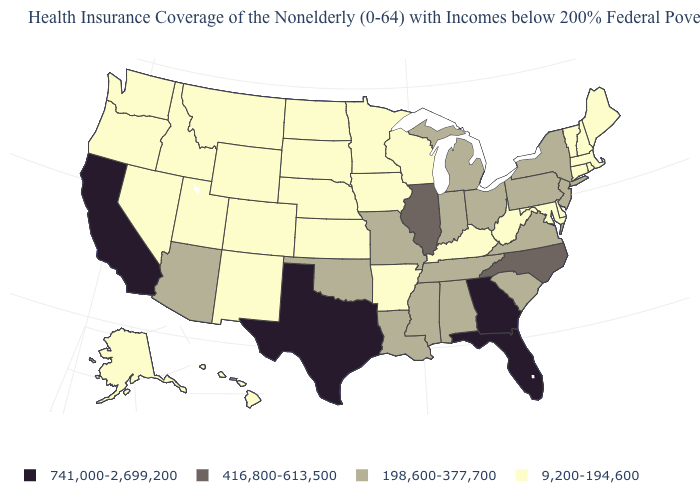Which states have the highest value in the USA?
Answer briefly. California, Florida, Georgia, Texas. Among the states that border Ohio , which have the lowest value?
Keep it brief. Kentucky, West Virginia. What is the value of New Hampshire?
Give a very brief answer. 9,200-194,600. What is the value of Ohio?
Concise answer only. 198,600-377,700. What is the value of Montana?
Concise answer only. 9,200-194,600. Name the states that have a value in the range 416,800-613,500?
Give a very brief answer. Illinois, North Carolina. What is the highest value in states that border Delaware?
Give a very brief answer. 198,600-377,700. What is the value of Maryland?
Answer briefly. 9,200-194,600. Name the states that have a value in the range 198,600-377,700?
Concise answer only. Alabama, Arizona, Indiana, Louisiana, Michigan, Mississippi, Missouri, New Jersey, New York, Ohio, Oklahoma, Pennsylvania, South Carolina, Tennessee, Virginia. Which states have the highest value in the USA?
Be succinct. California, Florida, Georgia, Texas. Among the states that border Maryland , does Delaware have the highest value?
Quick response, please. No. Name the states that have a value in the range 198,600-377,700?
Short answer required. Alabama, Arizona, Indiana, Louisiana, Michigan, Mississippi, Missouri, New Jersey, New York, Ohio, Oklahoma, Pennsylvania, South Carolina, Tennessee, Virginia. Does Vermont have the highest value in the Northeast?
Write a very short answer. No. What is the value of Oklahoma?
Quick response, please. 198,600-377,700. Is the legend a continuous bar?
Be succinct. No. 